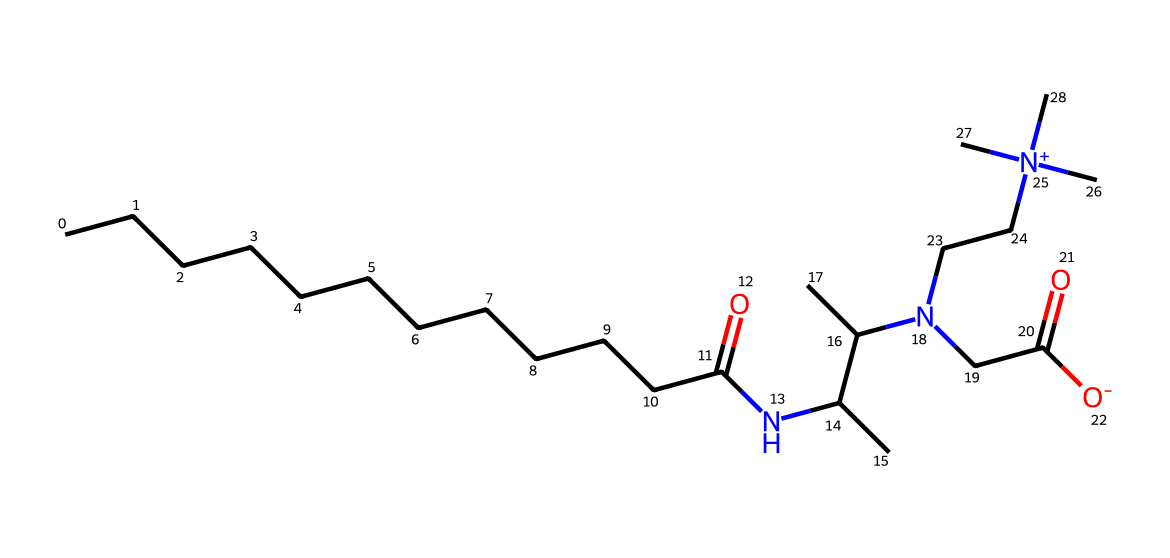What is the main functional group present in cocamidopropyl betaine? The SMILES representation indicates the presence of an amide functional group due to the =O and -N- connections. This is typical in betaines and surfactants, indicating the molecular structure.
Answer: amide How many nitrogen atoms are in the structure of cocamidopropyl betaine? By examining the SMILES notation, we can count the nitrogen atoms, which appear three times in the structure: one as part of the amide and two within the charged nitrogen.
Answer: three Which part of cocamidopropyl betaine contributes to its surfactant properties? The long carbon chain (hydrophobic tail) contributes to its surfactant properties, providing the nonpolar character that interacts with oils, while the cationic and anionic portions help to solubilize substances in water.
Answer: carbon chain What is the molecular formula of cocamidopropyl betaine? By interpreting the SMILES string, we can deduce the molecular formula includes carbon (C), hydrogen (H), nitrogen (N), and oxygen (O) atoms specifically to this molecule, leading to the exact composition.
Answer: C18H36N2O2 Is cocamidopropyl betaine cationic, anionic, or zwitterionic? The presence of both positive and negative charges in the structure (positive from the nitrogen and negative from the carboxylate) indicates that cocamidopropyl betaine is zwitterionic.
Answer: zwitterionic How does the structure of cocamidopropyl betaine aid in its solubility in water? The presence of the charged functional groups (like the cationic nitrogen and the anionic carboxylate) allows for strong interactions with water molecules, enhancing its solubility.
Answer: charged groups What type of surfactant is cocamidopropyl betaine classified as? Based on its molecular structure and the presence of both lipophilic and hydrophilic groups, it is classified as an amphoteric surfactant since it can carry both positive and negative charges depending on the pH.
Answer: amphoteric 